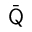Convert formula to latex. <formula><loc_0><loc_0><loc_500><loc_500>\bar { \mathsf Q }</formula> 